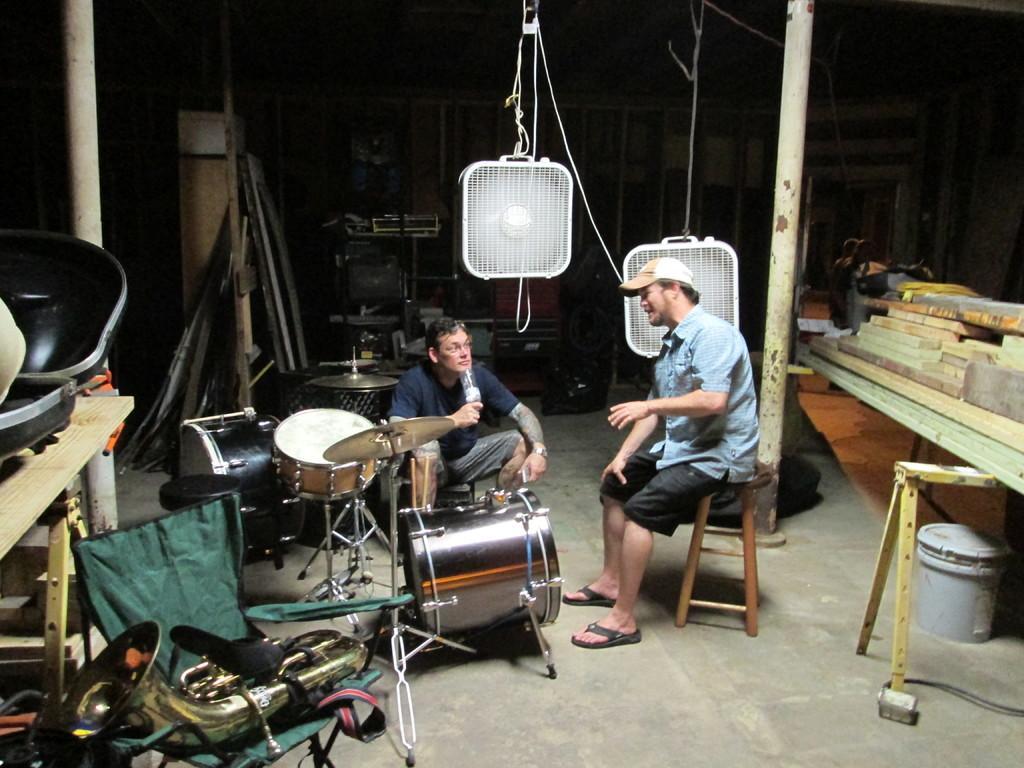In one or two sentences, can you explain what this image depicts? In this picture, we can see two persons, one of them are holding an object, we can see some objects on the ground like musical instruments, tables and some objects on it, we can see some objects in the background, and the poles. 